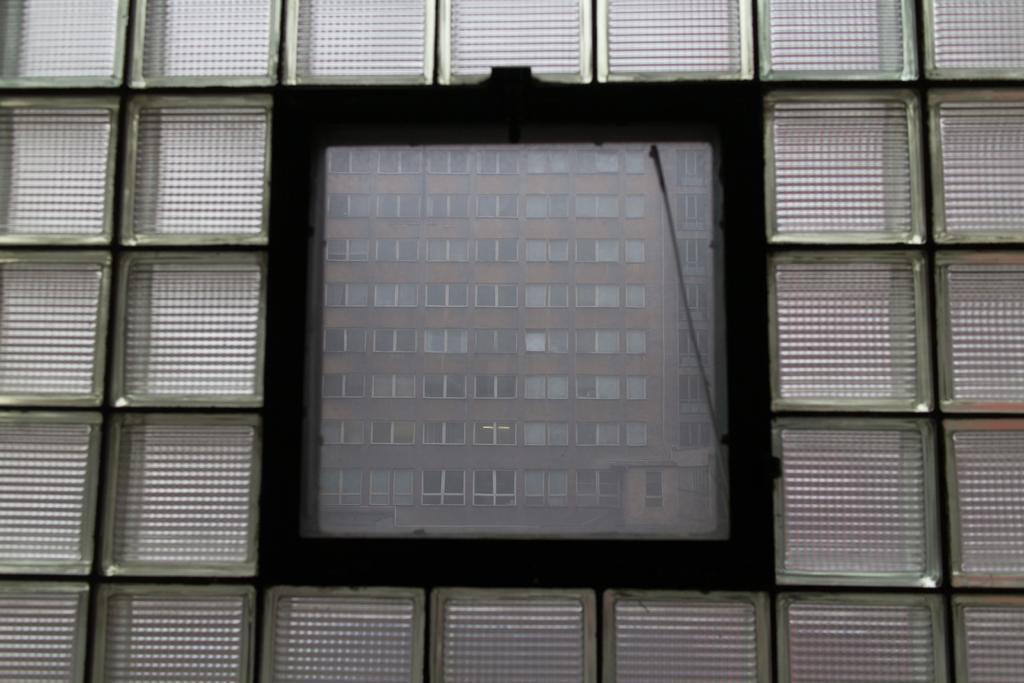Please provide a concise description of this image. In this image, this looks like a glass door. I can see the reflection of a building with the windows. 